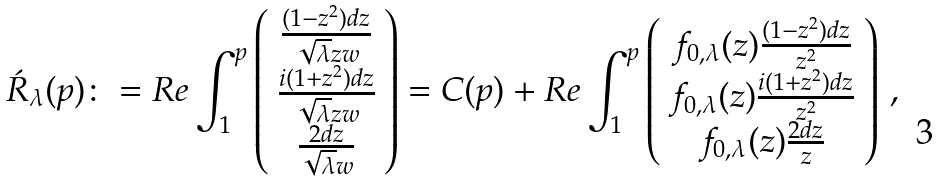<formula> <loc_0><loc_0><loc_500><loc_500>\acute { R } _ { \lambda } ( p ) \colon = R e \int _ { 1 } ^ { p } \left ( \begin{array} { c } \frac { ( 1 - z ^ { 2 } ) d z } { \sqrt { \lambda } z w } \\ \frac { i ( 1 + z ^ { 2 } ) d z } { \sqrt { \lambda } z w } \\ \frac { 2 d z } { \sqrt { \lambda } w } \end{array} \right ) = C ( p ) + R e \int _ { 1 } ^ { p } \left ( \begin{array} { c } f _ { 0 , \lambda } ( z ) \frac { ( 1 - z ^ { 2 } ) d z } { z ^ { 2 } } \\ f _ { 0 , \lambda } ( z ) \frac { i ( 1 + z ^ { 2 } ) d z } { z ^ { 2 } } \\ f _ { 0 , \lambda } ( z ) \frac { 2 d z } { z } \end{array} \right ) \, ,</formula> 